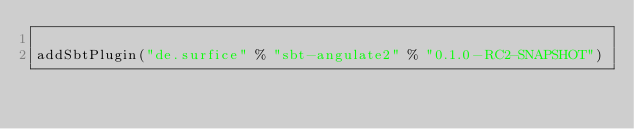Convert code to text. <code><loc_0><loc_0><loc_500><loc_500><_Scala_>
addSbtPlugin("de.surfice" % "sbt-angulate2" % "0.1.0-RC2-SNAPSHOT")


</code> 